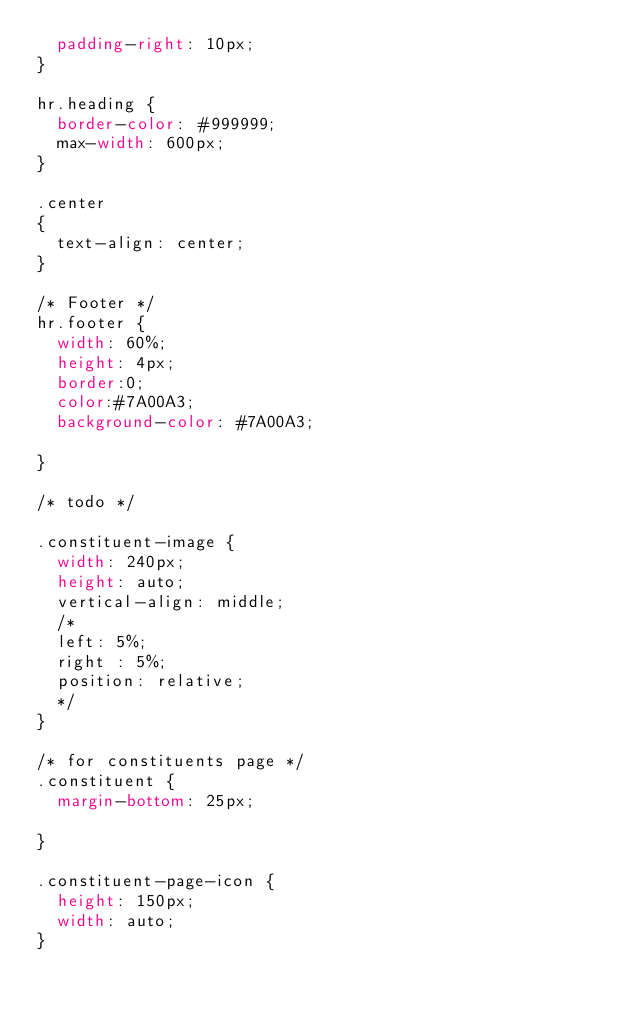<code> <loc_0><loc_0><loc_500><loc_500><_CSS_>	padding-right: 10px;
}

hr.heading {
	border-color: #999999;
	max-width: 600px;
}

.center
{
	text-align: center;
}

/* Footer */
hr.footer { 
	width: 60%;
	height: 4px;
	border:0;
	color:#7A00A3;
	background-color: #7A00A3;
	
}

/* todo */

.constituent-image {
	width: 240px;
	height: auto;
	vertical-align: middle;
	/*
	left: 5%;
	right : 5%;
	position: relative;
	*/
}

/* for constituents page */
.constituent {
	margin-bottom: 25px;

}

.constituent-page-icon {
	height: 150px;
	width: auto;
}</code> 